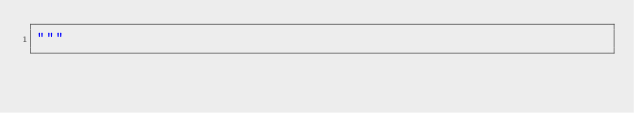Convert code to text. <code><loc_0><loc_0><loc_500><loc_500><_Python_>"""</code> 